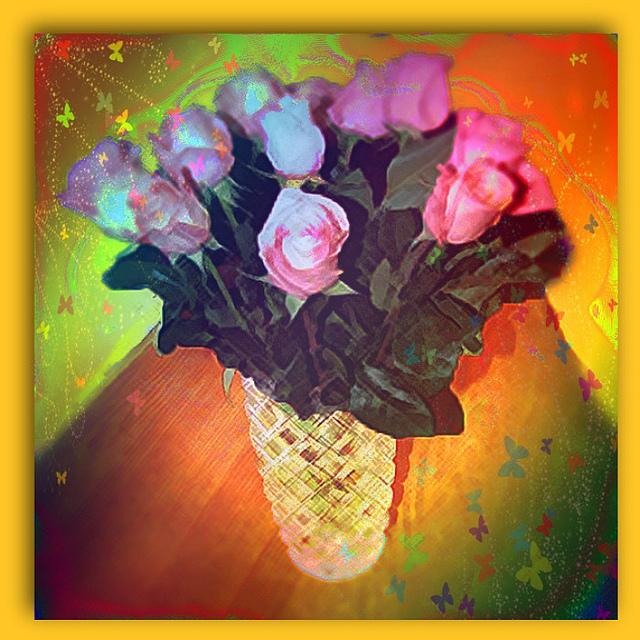What color are the flowers?
Answer briefly. Pink. Are there butterflies?
Quick response, please. Yes. What kind of flowers are these?
Short answer required. Roses. 